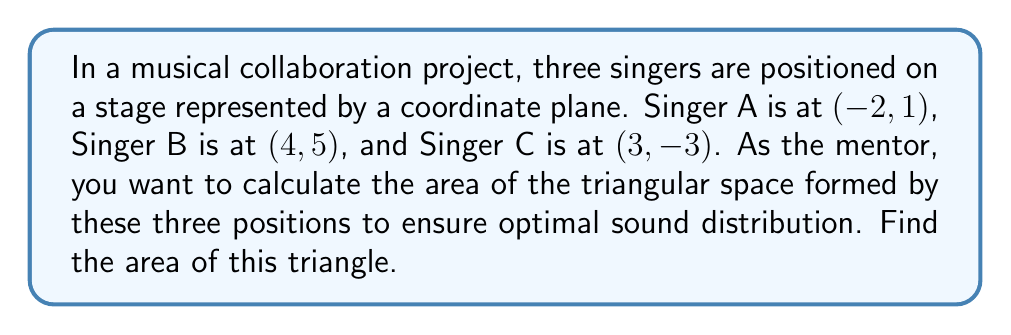Help me with this question. To find the area of a triangle given three points on a coordinate plane, we can use the formula:

$$ \text{Area} = \frac{1}{2}|x_1(y_2 - y_3) + x_2(y_3 - y_1) + x_3(y_1 - y_2)| $$

Where $(x_1, y_1)$, $(x_2, y_2)$, and $(x_3, y_3)$ are the coordinates of the three points.

Let's assign our points:
$(x_1, y_1) = (-2, 1)$ for Singer A
$(x_2, y_2) = (4, 5)$ for Singer B
$(x_3, y_3) = (3, -3)$ for Singer C

Now, let's substitute these values into our formula:

$$ \begin{align*}
\text{Area} &= \frac{1}{2}|(-2)(5 - (-3)) + (4)((-3) - 1) + (3)(1 - 5)| \\
&= \frac{1}{2}|(-2)(8) + (4)(-4) + (3)(-4)| \\
&= \frac{1}{2}|-16 - 16 - 12| \\
&= \frac{1}{2}|-44| \\
&= \frac{1}{2}(44) \\
&= 22
\end{align*} $$

Therefore, the area of the triangle is 22 square units.

[asy]
unitsize(20);
defaultpen(fontsize(10pt));

pair A = (-2,1);
pair B = (4,5);
pair C = (3,-3);

draw(A--B--C--cycle, rgb(0,0,1));

dot("A (-2, 1)", A, NW);
dot("B (4, 5)", B, NE);
dot("C (3, -3)", C, SE);

xaxis("x", arrow=Arrow);
yaxis("y", arrow=Arrow);

for(int i=-2; i<=4; ++i) {
  draw((i,-3.5)--(i,-3.3));
  label(format("%d", i), (i,-3.7), S);
}

for(int i=-3; i<=5; ++i) {
  draw((-2.2,i)--(-2,i));
  label(format("%d", i), (-2.4,i), W);
}
[/asy]
Answer: The area of the triangle formed by the three singers' positions is 22 square units. 